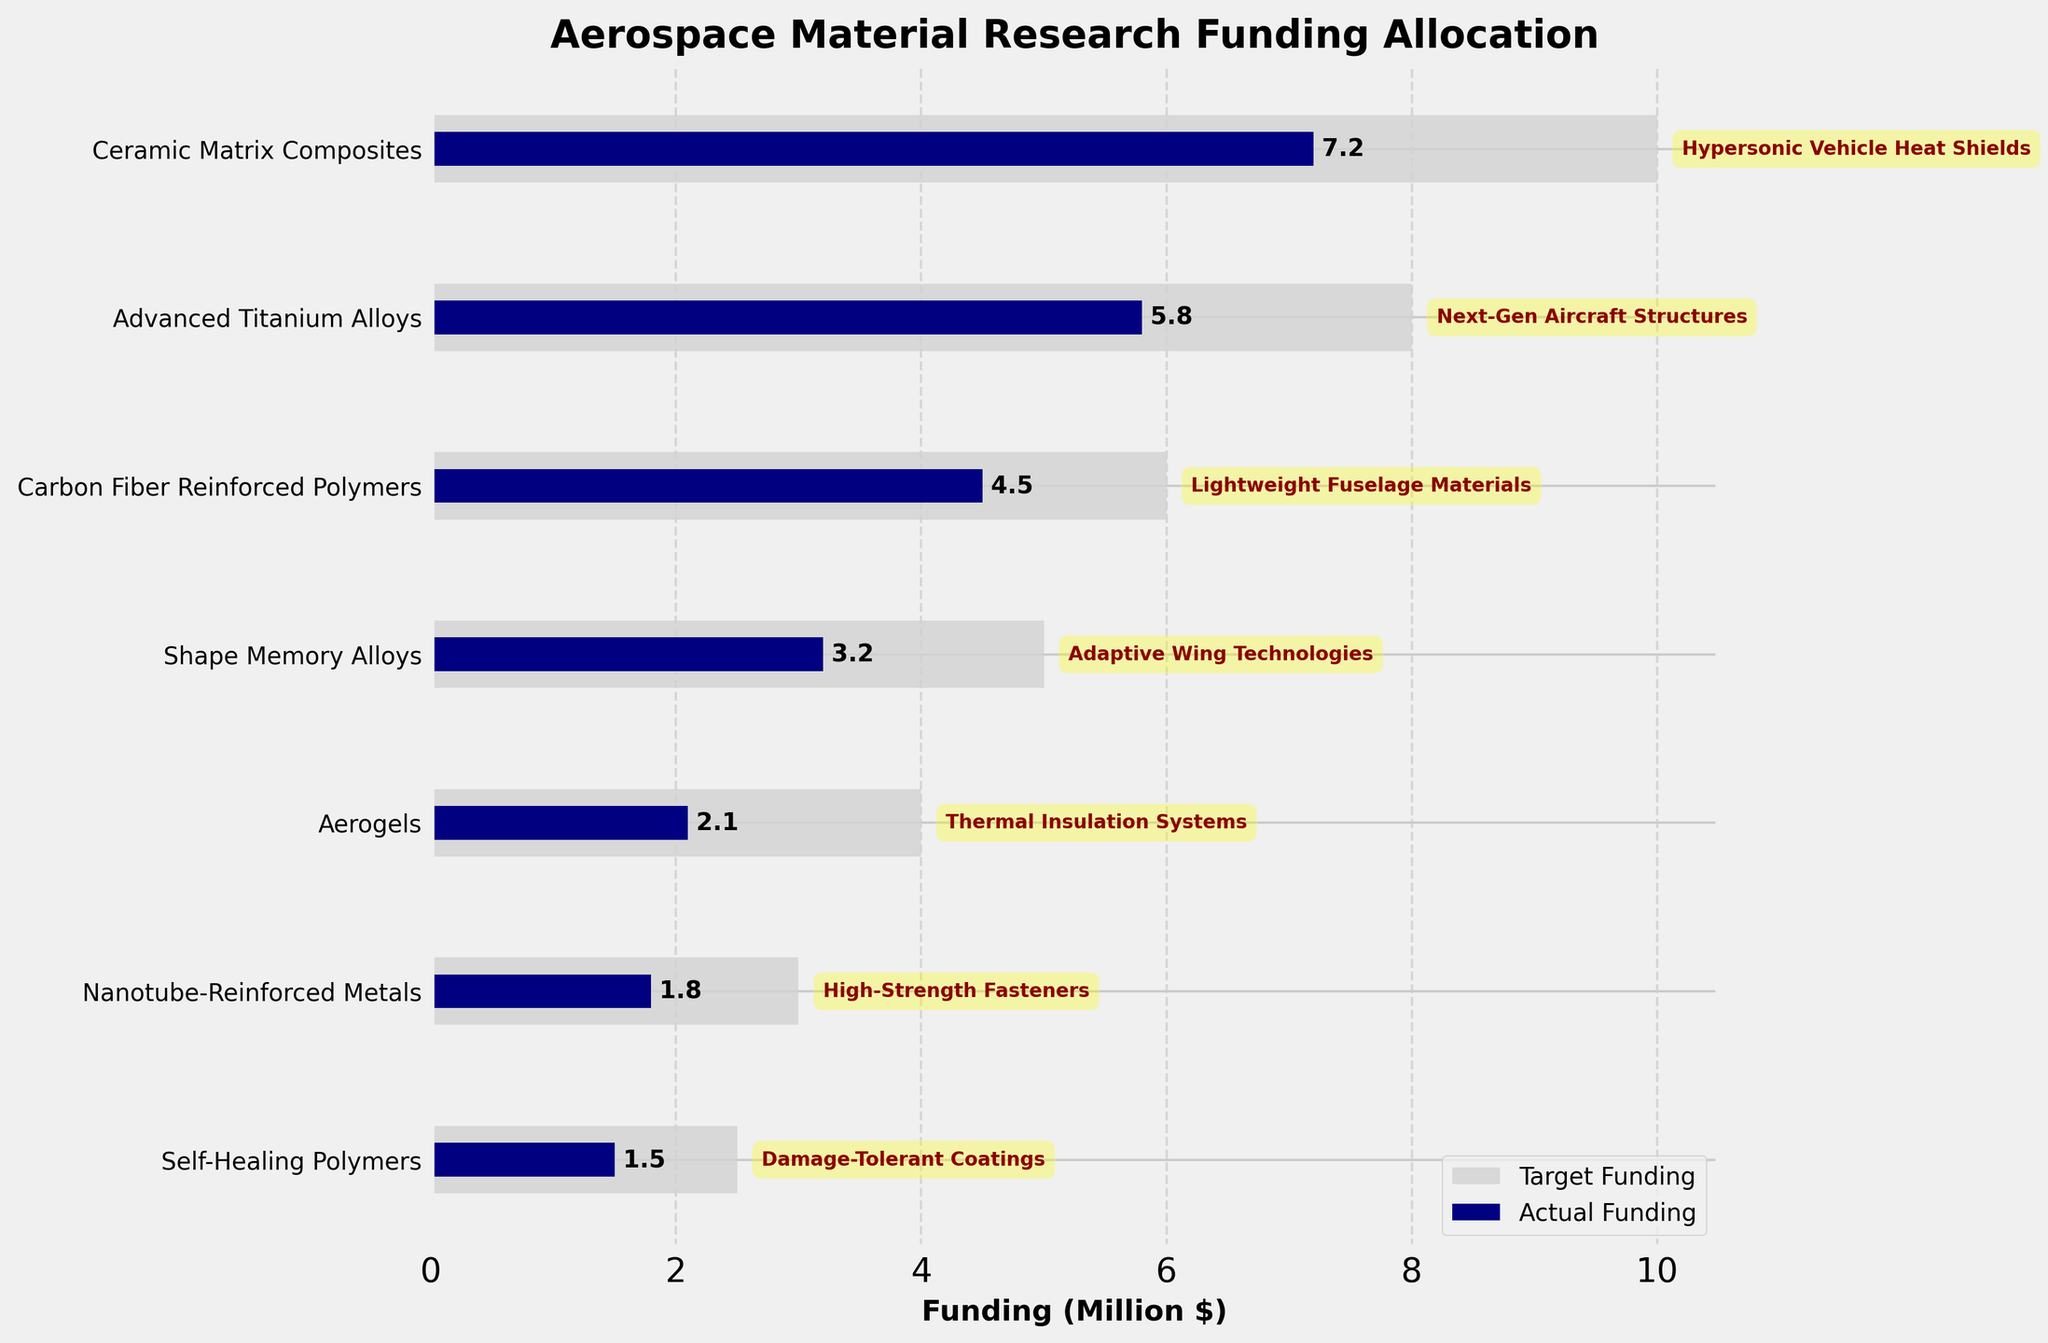How many categories are displayed on the chart? Count the number of distinct categories listed on the y-axis.
Answer: 7 What is the title of the figure? Look at the top of the chart where the title is usually placed.
Answer: Aerospace Material Research Funding Allocation Which category has the highest target funding? Compare the target funding bars for each category and identify the longest one.
Answer: Ceramic Matrix Composites By how much does the actual funding for 'Advanced Titanium Alloys' fall short of the target funding? Subtract the actual funding value for 'Advanced Titanium Alloys' from its target funding value: 8 - 5.8
Answer: 2.2 What is the project goal for 'Aerogels'? Read the annotation attached to the 'Aerogels' bar.
Answer: Thermal Insulation Systems Which category is closest to meeting its target funding, and how far is it from the target? Compare the difference between actual and target fundings for each category and find the smallest difference. For 'Self-Healing Polymers', it's 2.5 - 1.5.
Answer: Self-Healing Polymers, 1 How many categories have an actual funding of more than 4 million dollars? Count the number of categories where the actual funding bar is longer than 4 units on the x-axis.
Answer: 2 What is the combined actual funding for all categories? Sum the actual funding values: 7.2 + 5.8 + 4.5 + 3.2 + 2.1 + 1.8 + 1.5
Answer: 26.1 Which category has the largest discrepancy between actual and target funding? Subtract the actual funding from the target funding for each category and find the one with the largest difference. For 'Ceramic Matrix Composites', it's 10 - 7.2.
Answer: Ceramic Matrix Composites Which two categories have the lowest target funding, and what are their target funding values? Identify the two lowest target funding values and their corresponding categories: 'Self-Healing Polymers' and 'Nanotube-Reinforced Metals'.
Answer: Self-Healing Polymers (2.5), Nanotube-Reinforced Metals (3) 